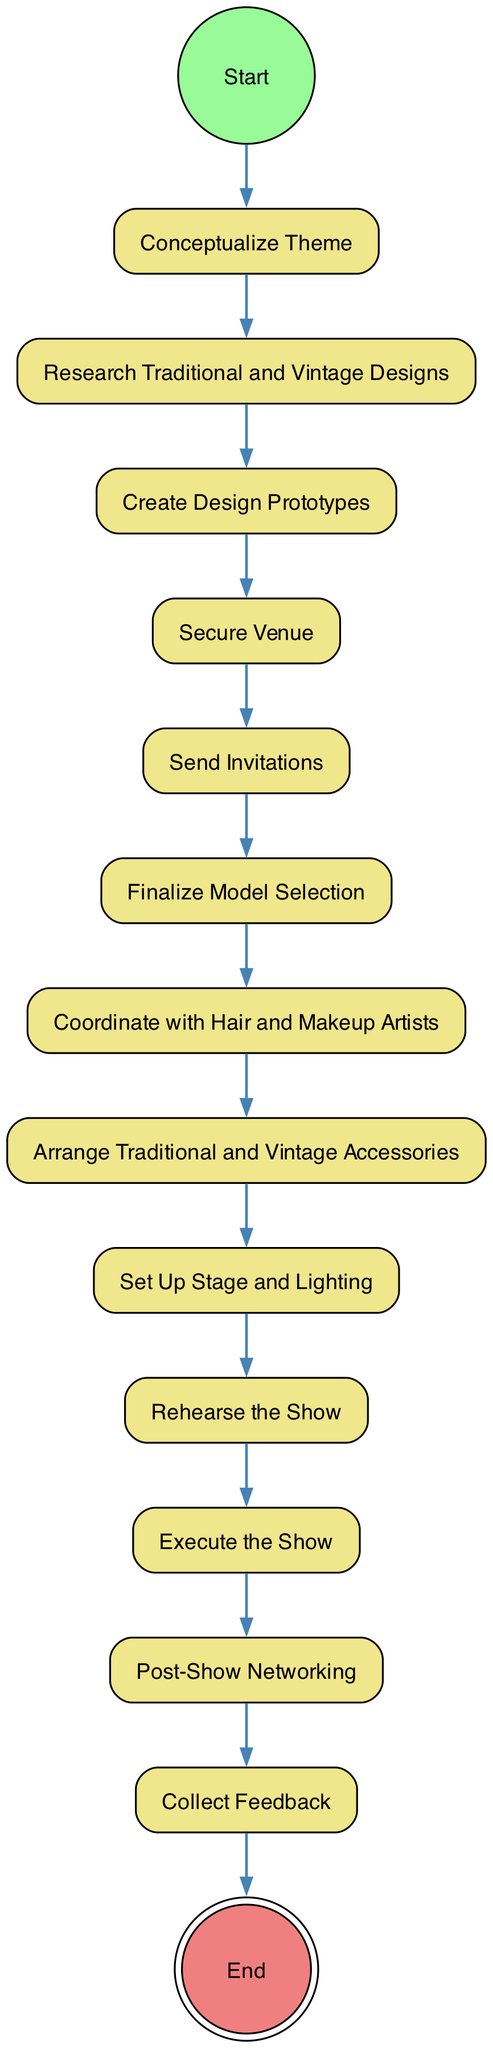What is the first activity in the diagram? The first activity, following the Start node, is "Conceptualize Theme." This is evident because the transition from "Start" leads directly to "Conceptualize Theme."
Answer: Conceptualize Theme How many nodes are there in total? To find the total number of nodes, we count each distinct activity and special nodes (Start and End). There are 14 nodes in total, consisting of 12 activities, 1 initial node, and 1 final node.
Answer: 14 What is the last activity before the show execution? The last activity before executing the show is "Rehearse the Show," which immediately precedes "Execute the Show" based on the directed flow shown in the diagram.
Answer: Rehearse the Show Which activity is connected directly to "Secure Venue"? The activity directly connected to "Secure Venue" is "Send Invitations," as indicated by the transition from "Secure Venue" leading to "Send Invitations."
Answer: Send Invitations What is the main focus of the show before model selection? The main focus of the show prior to model selection is "Coordinate with Hair and Makeup Artists," which is highlighted as the step immediately following "Finalize Model Selection."
Answer: Coordinate with Hair and Makeup Artists How are "Post-Show Networking" and "Collect Feedback" related? "Post-Show Networking" leads directly into "Collect Feedback," creating a sequence where the latter typically follows the former as part of the post-show activities.
Answer: Sequential activities What type of diagram is represented here? The diagram represents an Activity Diagram, which is used to illustrate the workflow or processes involved in organizing events, particularly the steps taken in a fashion show.
Answer: Activity Diagram How many transitions are present in the diagram? The total number of transitions can be counted by reviewing each directed connection between nodes. There are 13 transitions present in the diagram.
Answer: 13 What comes after "Arrange Traditional and Vintage Accessories"? The activity that follows "Arrange Traditional and Vintage Accessories" is "Set Up Stage and Lighting," as shown by the directed flow following that activity.
Answer: Set Up Stage and Lighting 